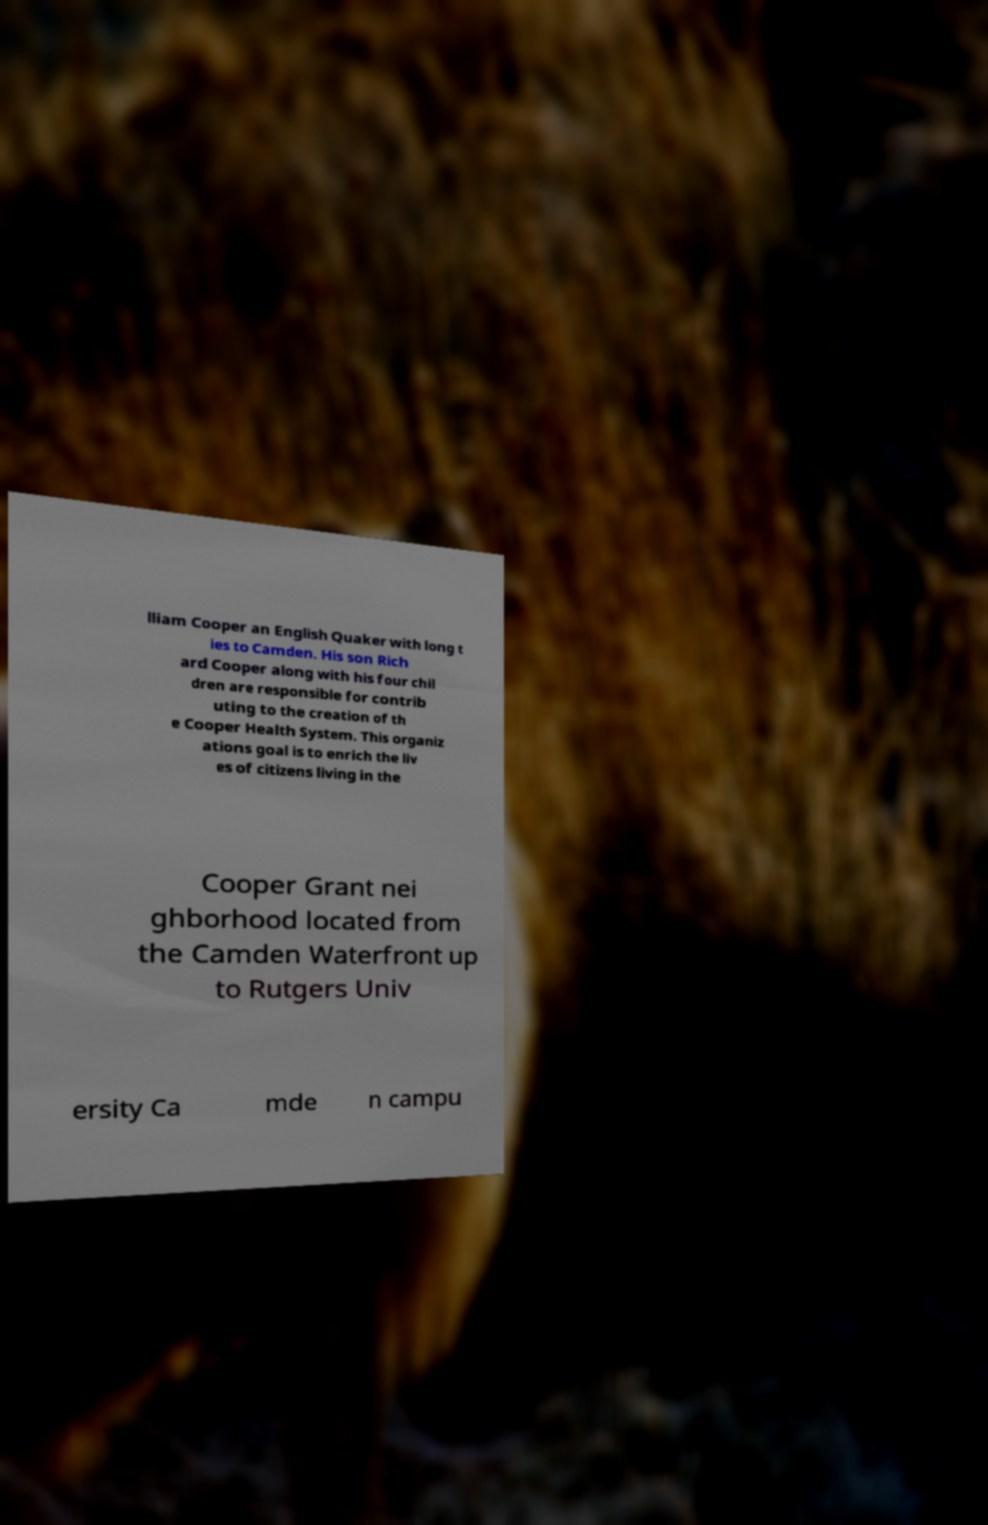I need the written content from this picture converted into text. Can you do that? lliam Cooper an English Quaker with long t ies to Camden. His son Rich ard Cooper along with his four chil dren are responsible for contrib uting to the creation of th e Cooper Health System. This organiz ations goal is to enrich the liv es of citizens living in the Cooper Grant nei ghborhood located from the Camden Waterfront up to Rutgers Univ ersity Ca mde n campu 